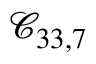<formula> <loc_0><loc_0><loc_500><loc_500>\mathcal { C } _ { 3 3 , 7 }</formula> 